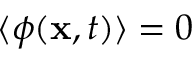<formula> <loc_0><loc_0><loc_500><loc_500>\langle \phi ( x , t ) \rangle = 0</formula> 